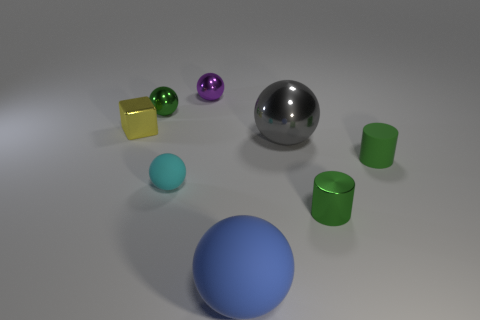Is there anything else of the same color as the small matte cylinder?
Ensure brevity in your answer.  Yes. How many objects are either small spheres that are behind the big gray shiny thing or small green objects that are on the left side of the large matte thing?
Make the answer very short. 2. What is the shape of the matte object that is both right of the cyan rubber sphere and in front of the small green rubber cylinder?
Ensure brevity in your answer.  Sphere. There is a green shiny object behind the metal block; what number of small metallic cylinders are to the left of it?
Give a very brief answer. 0. Is there anything else that has the same material as the tiny purple object?
Your response must be concise. Yes. How many things are green objects that are to the right of the tiny green shiny sphere or tiny cylinders?
Provide a succinct answer. 2. There is a green object that is behind the large gray metal thing; what size is it?
Ensure brevity in your answer.  Small. What material is the small purple ball?
Give a very brief answer. Metal. There is a rubber thing on the left side of the ball that is behind the green sphere; what is its shape?
Provide a succinct answer. Sphere. How many other objects are the same shape as the cyan object?
Make the answer very short. 4. 